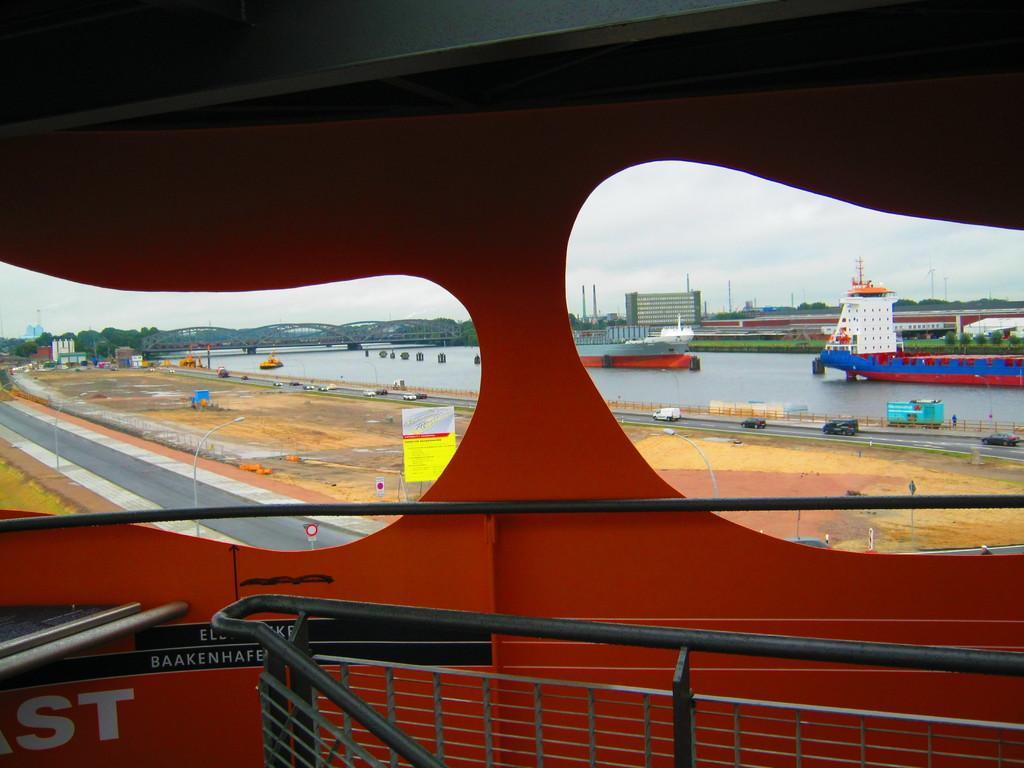What type of structure can be seen in the image? There is a railing in the image. What can be seen through the railing? Roads and land are visible through the railing. What type of vehicles are present on the roads? Cars are present on the roads. What type of watercraft can be seen in the image? Ships are visible on a river. What type of man-made structure is present in the image? There is a bridge in the image. What type of natural elements can be seen in the image? Trees are visible in the image. What type of buildings are present in the image? Buildings are present in the image. What part of the natural environment is visible in the image? The sky is visible in the image. What type of meat is being served for dinner in the image? There is no dinner or meat present in the image. 